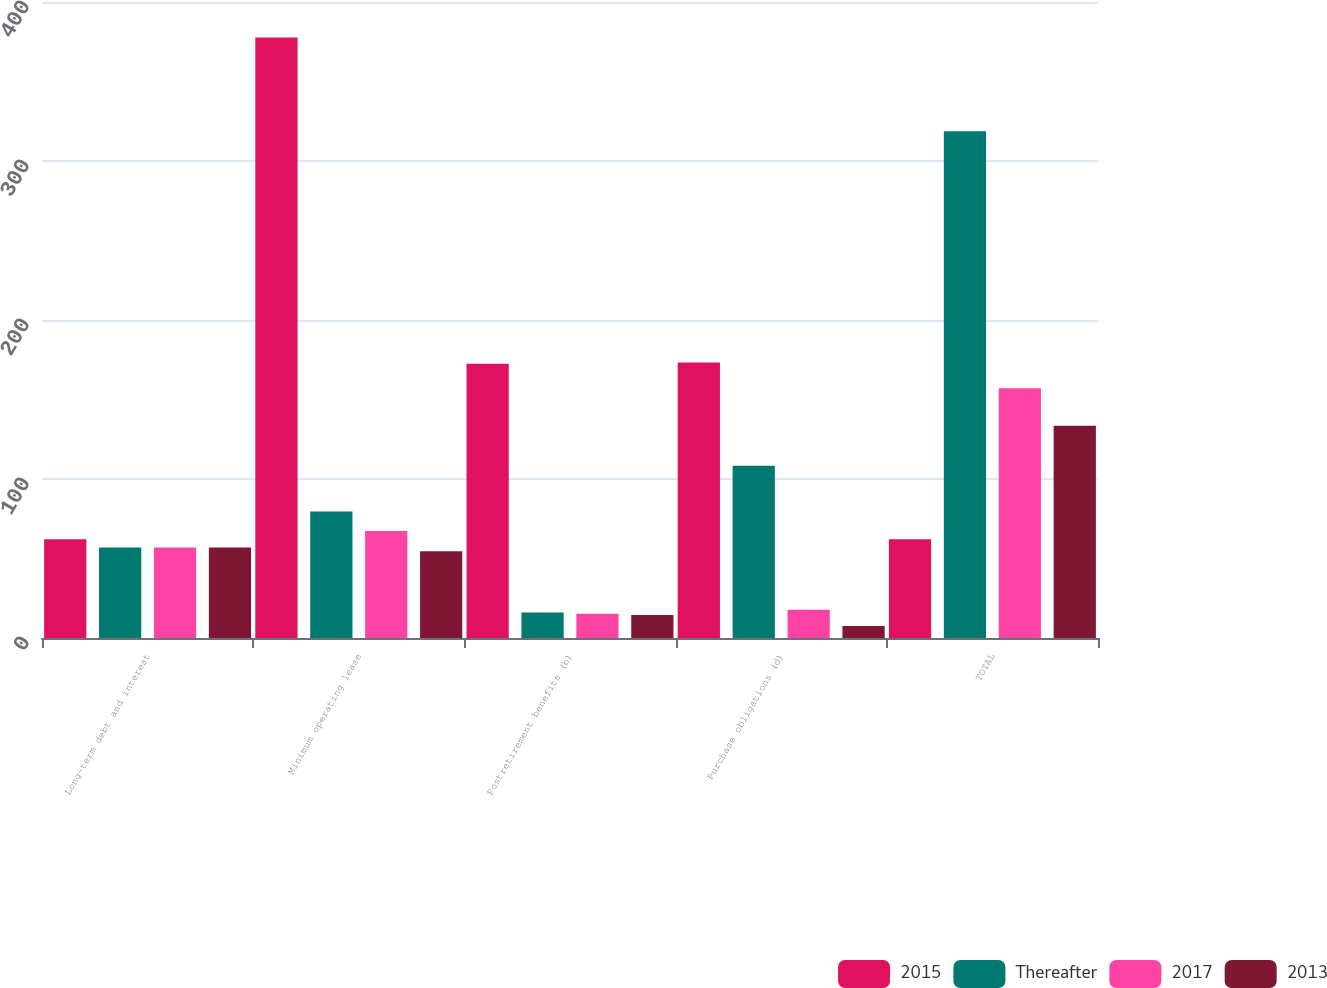Convert chart to OTSL. <chart><loc_0><loc_0><loc_500><loc_500><stacked_bar_chart><ecel><fcel>Long-term debt and interest<fcel>Minimum operating lease<fcel>Postretirement benefits (b)<fcel>Purchase obligations (d)<fcel>TOTAL<nl><fcel>2015<fcel>62.1<fcel>377.6<fcel>172.5<fcel>173.2<fcel>62.1<nl><fcel>Thereafter<fcel>56.9<fcel>79.6<fcel>16.1<fcel>108.4<fcel>318.7<nl><fcel>2017<fcel>56.9<fcel>67.3<fcel>15.2<fcel>17.7<fcel>157.1<nl><fcel>2013<fcel>56.9<fcel>54.5<fcel>14.5<fcel>7.6<fcel>133.5<nl></chart> 